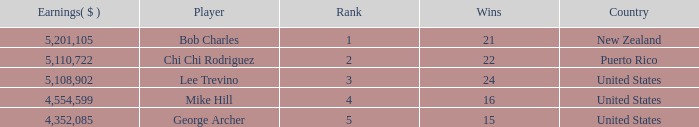What is the lowest level of Earnings($) to have a Wins value of 22 and a Rank lower than 2? None. 